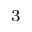Convert formula to latex. <formula><loc_0><loc_0><loc_500><loc_500>_ { 3 }</formula> 